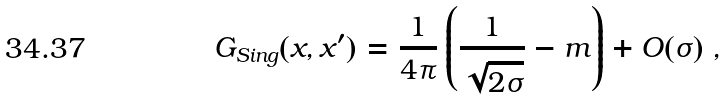Convert formula to latex. <formula><loc_0><loc_0><loc_500><loc_500>G _ { S i n g } ( x , x ^ { \prime } ) = \frac { 1 } { 4 \pi } \left ( \frac { 1 } { \sqrt { 2 \sigma } } - m \right ) + O ( \sigma ) \ ,</formula> 